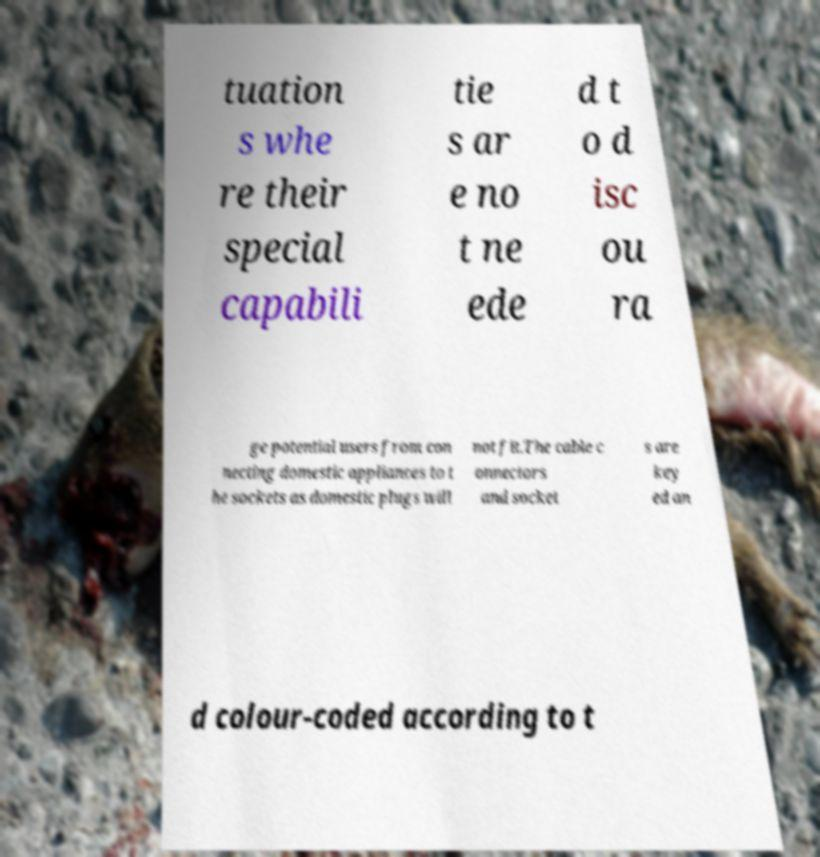Could you extract and type out the text from this image? tuation s whe re their special capabili tie s ar e no t ne ede d t o d isc ou ra ge potential users from con necting domestic appliances to t he sockets as domestic plugs will not fit.The cable c onnectors and socket s are key ed an d colour-coded according to t 